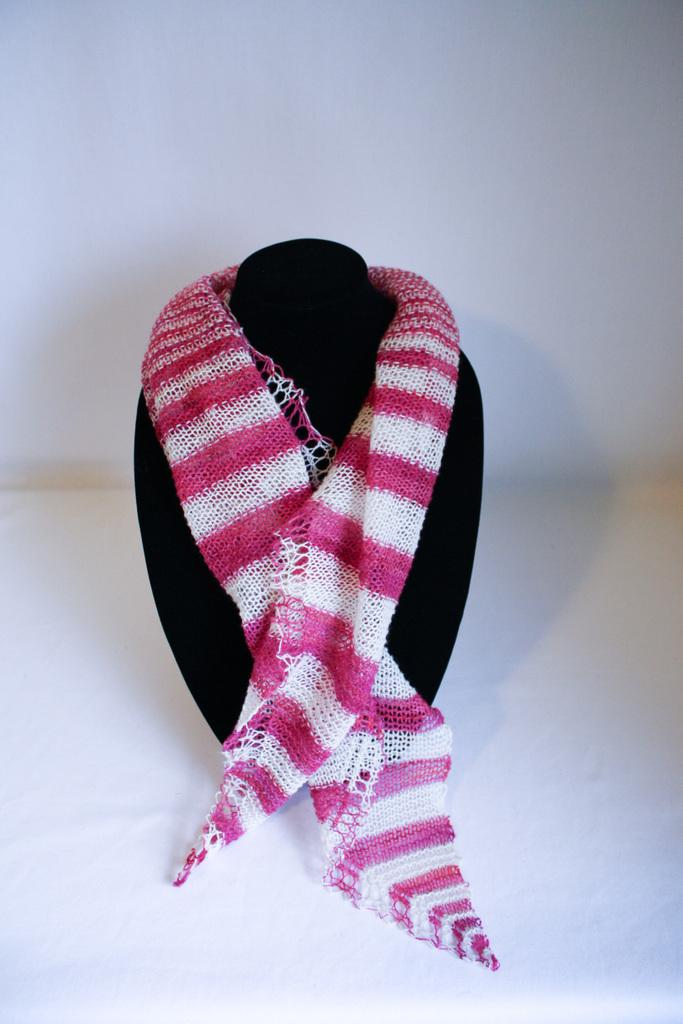What is present on the mannequin in the image? There is a scarf on the mannequin in the image. What is the color of the background in the image? The background of the image is white. What type of bottle is being used to give the mannequin a haircut in the image? There is no bottle or haircut present in the image; it features a scarf on a mannequin with a white background. 